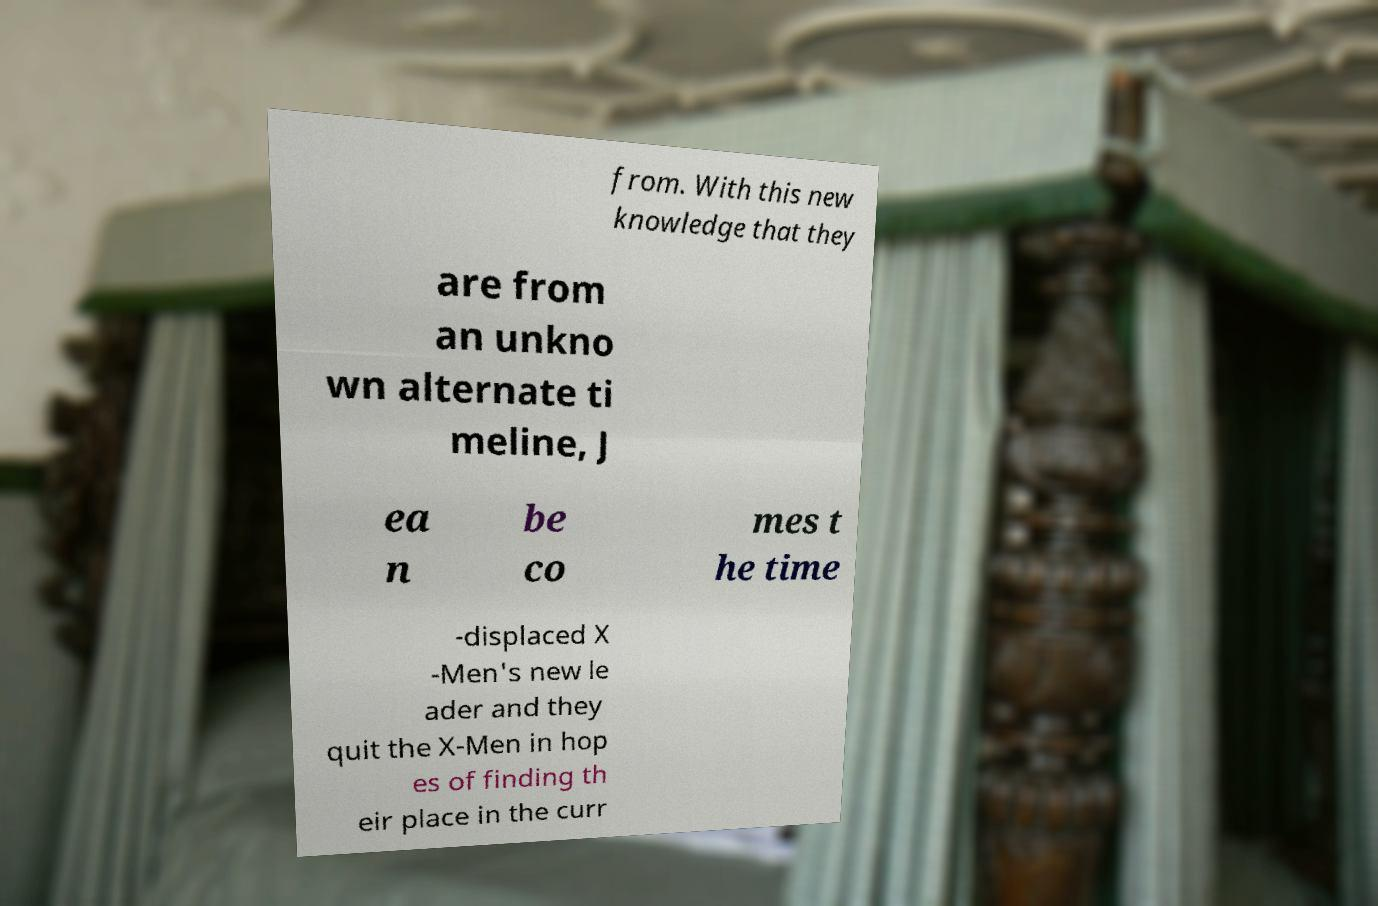What messages or text are displayed in this image? I need them in a readable, typed format. from. With this new knowledge that they are from an unkno wn alternate ti meline, J ea n be co mes t he time -displaced X -Men's new le ader and they quit the X-Men in hop es of finding th eir place in the curr 